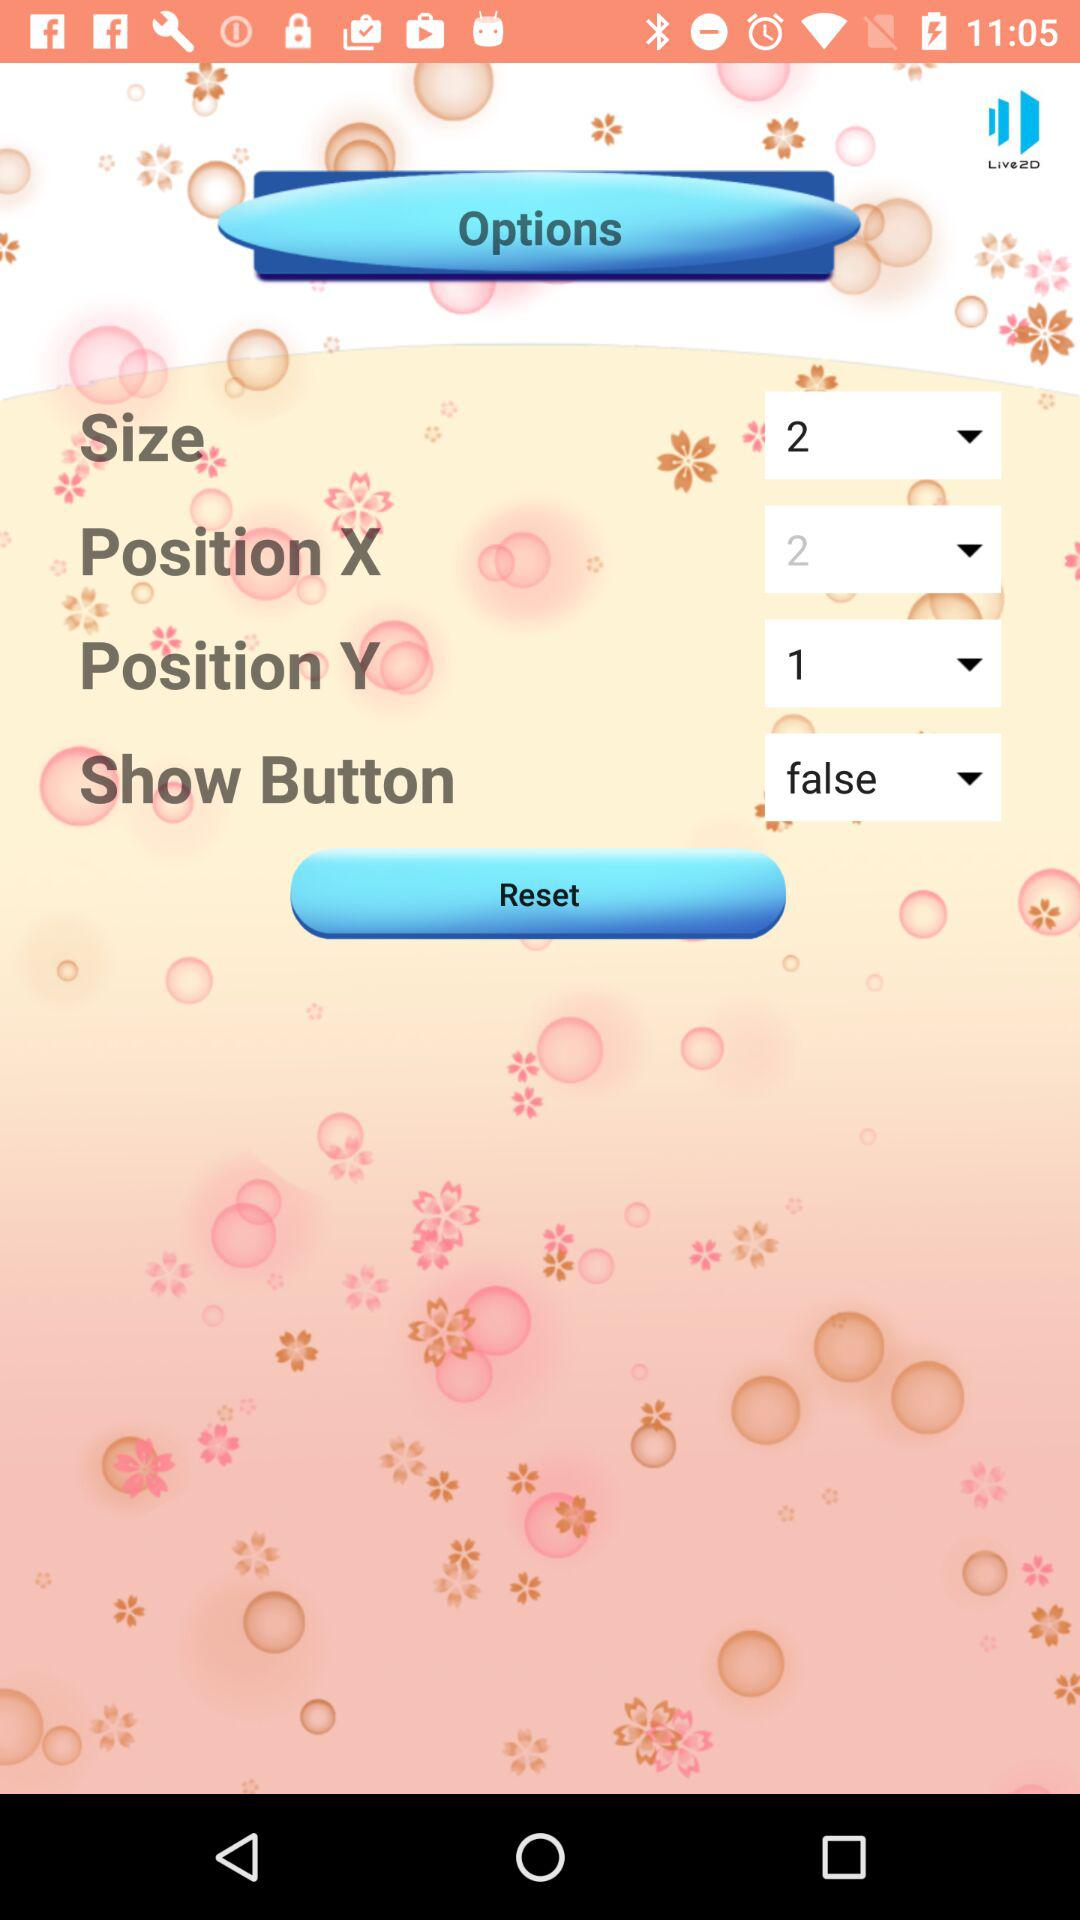What is the distance between the position X and position Y values?
Answer the question using a single word or phrase. 1 